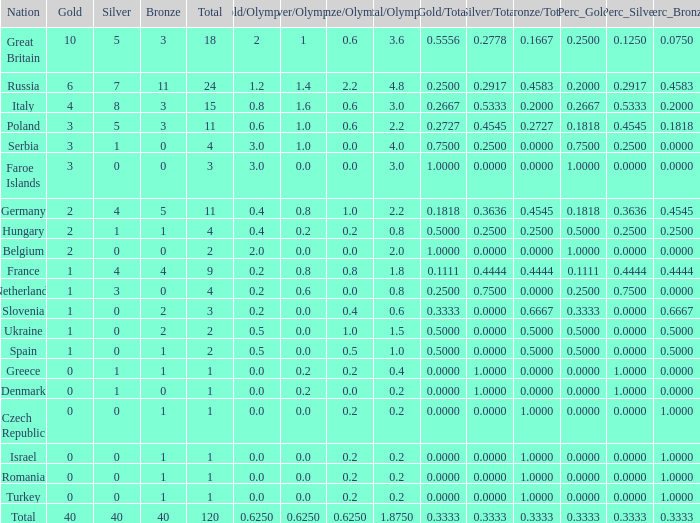What Nation has a Gold entry that is greater than 0, a Total that is greater than 2, a Silver entry that is larger than 1, and 0 Bronze? Netherlands. 